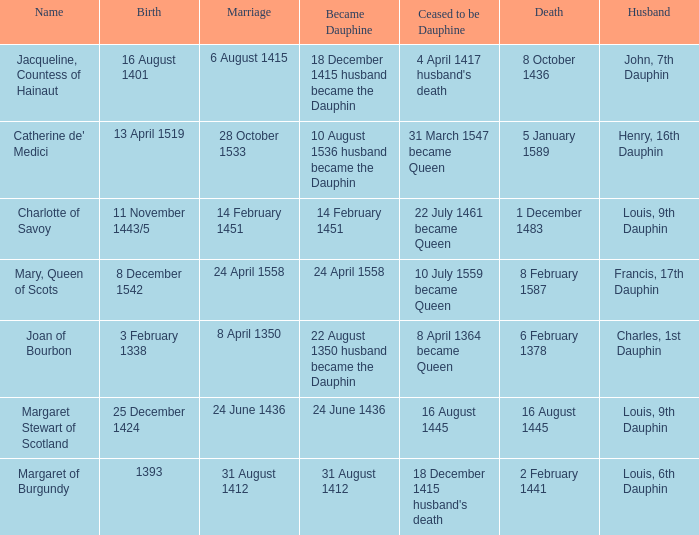When was the death when the birth was 8 december 1542? 8 February 1587. 